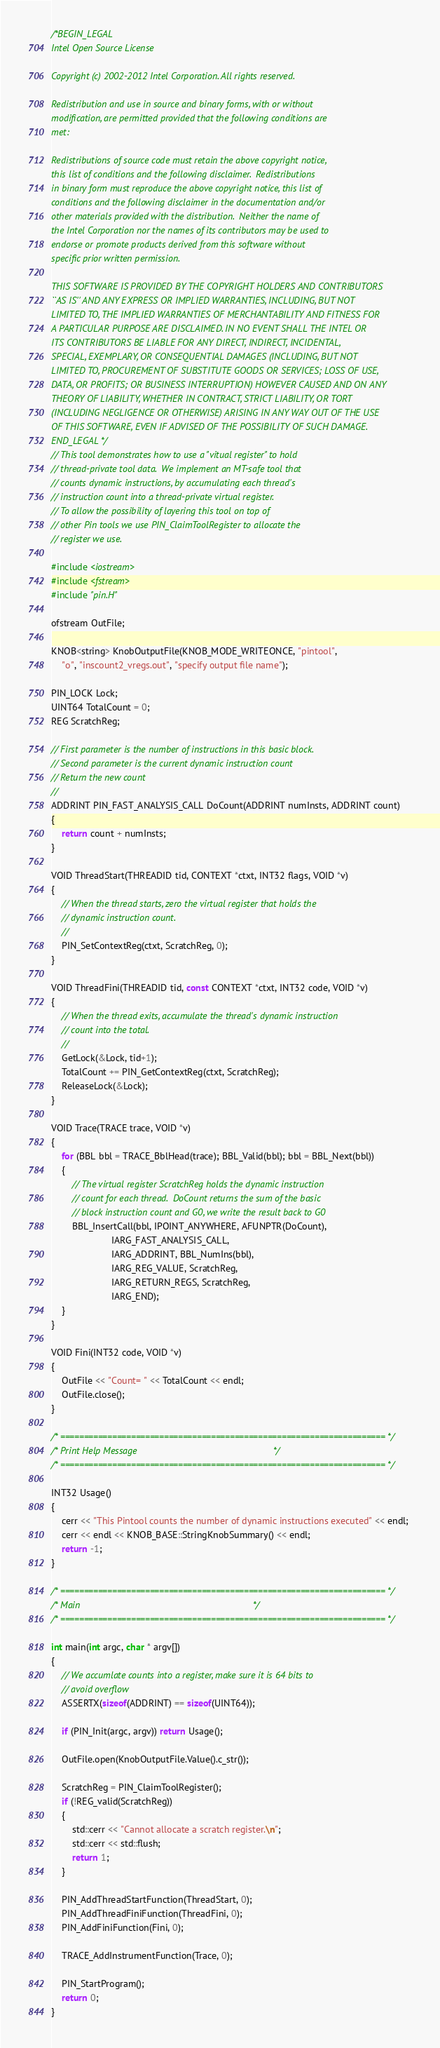<code> <loc_0><loc_0><loc_500><loc_500><_C++_>/*BEGIN_LEGAL 
Intel Open Source License 

Copyright (c) 2002-2012 Intel Corporation. All rights reserved.
 
Redistribution and use in source and binary forms, with or without
modification, are permitted provided that the following conditions are
met:

Redistributions of source code must retain the above copyright notice,
this list of conditions and the following disclaimer.  Redistributions
in binary form must reproduce the above copyright notice, this list of
conditions and the following disclaimer in the documentation and/or
other materials provided with the distribution.  Neither the name of
the Intel Corporation nor the names of its contributors may be used to
endorse or promote products derived from this software without
specific prior written permission.
 
THIS SOFTWARE IS PROVIDED BY THE COPYRIGHT HOLDERS AND CONTRIBUTORS
``AS IS'' AND ANY EXPRESS OR IMPLIED WARRANTIES, INCLUDING, BUT NOT
LIMITED TO, THE IMPLIED WARRANTIES OF MERCHANTABILITY AND FITNESS FOR
A PARTICULAR PURPOSE ARE DISCLAIMED. IN NO EVENT SHALL THE INTEL OR
ITS CONTRIBUTORS BE LIABLE FOR ANY DIRECT, INDIRECT, INCIDENTAL,
SPECIAL, EXEMPLARY, OR CONSEQUENTIAL DAMAGES (INCLUDING, BUT NOT
LIMITED TO, PROCUREMENT OF SUBSTITUTE GOODS OR SERVICES; LOSS OF USE,
DATA, OR PROFITS; OR BUSINESS INTERRUPTION) HOWEVER CAUSED AND ON ANY
THEORY OF LIABILITY, WHETHER IN CONTRACT, STRICT LIABILITY, OR TORT
(INCLUDING NEGLIGENCE OR OTHERWISE) ARISING IN ANY WAY OUT OF THE USE
OF THIS SOFTWARE, EVEN IF ADVISED OF THE POSSIBILITY OF SUCH DAMAGE.
END_LEGAL */
// This tool demonstrates how to use a "vitual register" to hold
// thread-private tool data.  We implement an MT-safe tool that
// counts dynamic instructions, by accumulating each thread's
// instruction count into a thread-private virtual register.
// To allow the possibility of layering this tool on top of
// other Pin tools we use PIN_ClaimToolRegister to allocate the
// register we use.

#include <iostream>
#include <fstream>
#include "pin.H"

ofstream OutFile;

KNOB<string> KnobOutputFile(KNOB_MODE_WRITEONCE, "pintool",
    "o", "inscount2_vregs.out", "specify output file name");

PIN_LOCK Lock;
UINT64 TotalCount = 0;
REG ScratchReg;

// First parameter is the number of instructions in this basic block.
// Second parameter is the current dynamic instruction count
// Return the new count
//
ADDRINT PIN_FAST_ANALYSIS_CALL DoCount(ADDRINT numInsts, ADDRINT count)
{
    return count + numInsts;
}

VOID ThreadStart(THREADID tid, CONTEXT *ctxt, INT32 flags, VOID *v)
{
    // When the thread starts, zero the virtual register that holds the
    // dynamic instruction count.
    //
    PIN_SetContextReg(ctxt, ScratchReg, 0);
}

VOID ThreadFini(THREADID tid, const CONTEXT *ctxt, INT32 code, VOID *v)
{
    // When the thread exits, accumulate the thread's dynamic instruction
    // count into the total.
    //
    GetLock(&Lock, tid+1);
    TotalCount += PIN_GetContextReg(ctxt, ScratchReg);
    ReleaseLock(&Lock);
}

VOID Trace(TRACE trace, VOID *v)
{
    for (BBL bbl = TRACE_BblHead(trace); BBL_Valid(bbl); bbl = BBL_Next(bbl))
    {
        // The virtual register ScratchReg holds the dynamic instruction
        // count for each thread.  DoCount returns the sum of the basic
        // block instruction count and G0, we write the result back to G0
        BBL_InsertCall(bbl, IPOINT_ANYWHERE, AFUNPTR(DoCount),
                       IARG_FAST_ANALYSIS_CALL,
                       IARG_ADDRINT, BBL_NumIns(bbl),
                       IARG_REG_VALUE, ScratchReg,
                       IARG_RETURN_REGS, ScratchReg,
                       IARG_END);
    }
}

VOID Fini(INT32 code, VOID *v)
{
    OutFile << "Count= " << TotalCount << endl;
    OutFile.close();
}

/* ===================================================================== */
/* Print Help Message                                                    */
/* ===================================================================== */

INT32 Usage()
{
    cerr << "This Pintool counts the number of dynamic instructions executed" << endl;
    cerr << endl << KNOB_BASE::StringKnobSummary() << endl;
    return -1;
}

/* ===================================================================== */
/* Main                                                                  */
/* ===================================================================== */

int main(int argc, char * argv[])
{
    // We accumlate counts into a register, make sure it is 64 bits to
    // avoid overflow
    ASSERTX(sizeof(ADDRINT) == sizeof(UINT64));
    
    if (PIN_Init(argc, argv)) return Usage();

    OutFile.open(KnobOutputFile.Value().c_str());

    ScratchReg = PIN_ClaimToolRegister();
    if (!REG_valid(ScratchReg))
    {
        std::cerr << "Cannot allocate a scratch register.\n";
        std::cerr << std::flush;
        return 1;
    }

    PIN_AddThreadStartFunction(ThreadStart, 0);
    PIN_AddThreadFiniFunction(ThreadFini, 0);
    PIN_AddFiniFunction(Fini, 0);

    TRACE_AddInstrumentFunction(Trace, 0);

    PIN_StartProgram();
    return 0;
}
</code> 